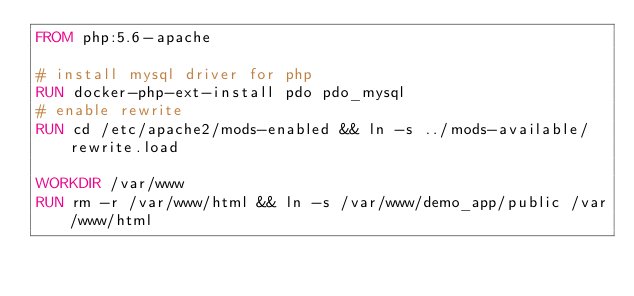Convert code to text. <code><loc_0><loc_0><loc_500><loc_500><_Dockerfile_>FROM php:5.6-apache

# install mysql driver for php
RUN docker-php-ext-install pdo pdo_mysql
# enable rewrite
RUN cd /etc/apache2/mods-enabled && ln -s ../mods-available/rewrite.load 

WORKDIR /var/www
RUN rm -r /var/www/html && ln -s /var/www/demo_app/public /var/www/html
</code> 